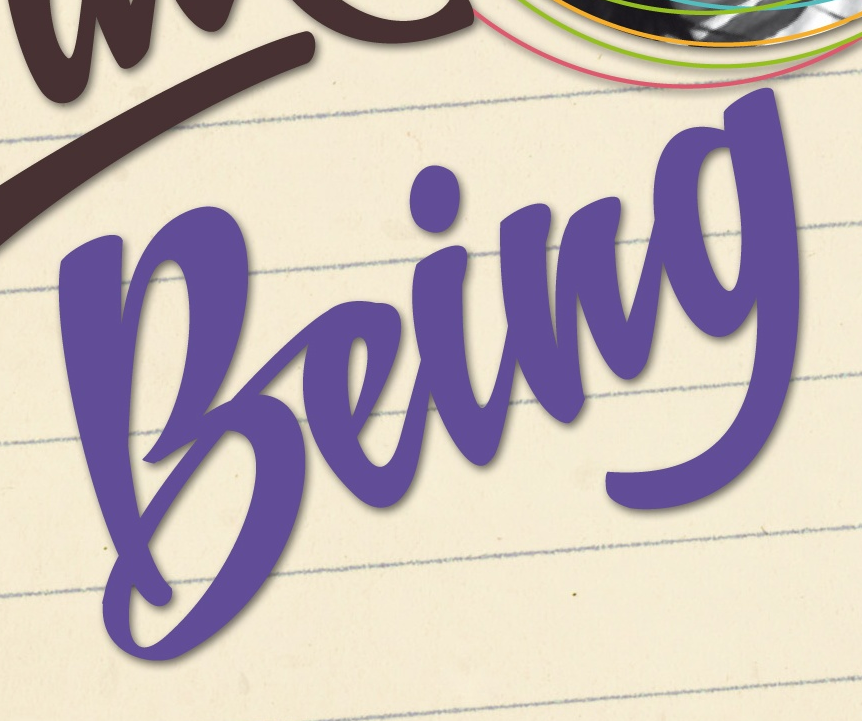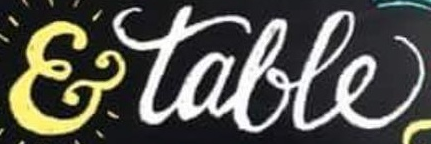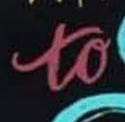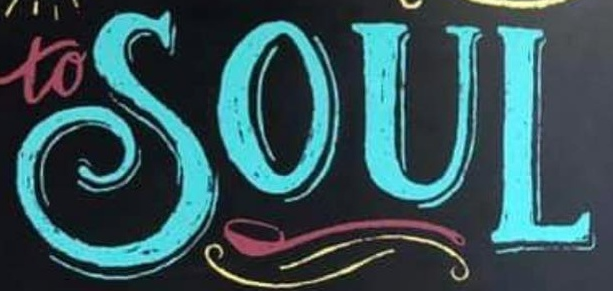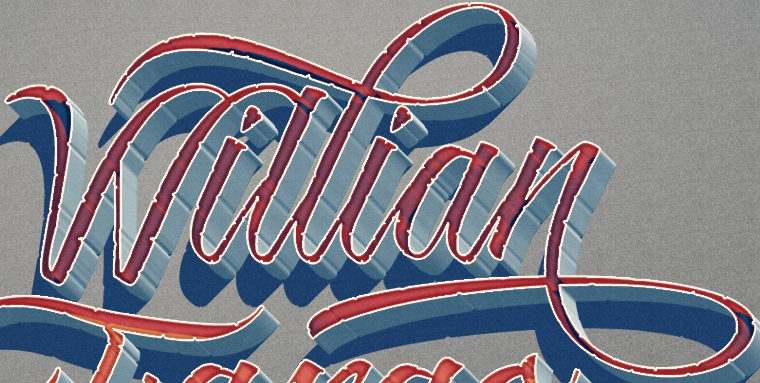What text is displayed in these images sequentially, separated by a semicolon? being; &talle; to; SOUL; Willian 